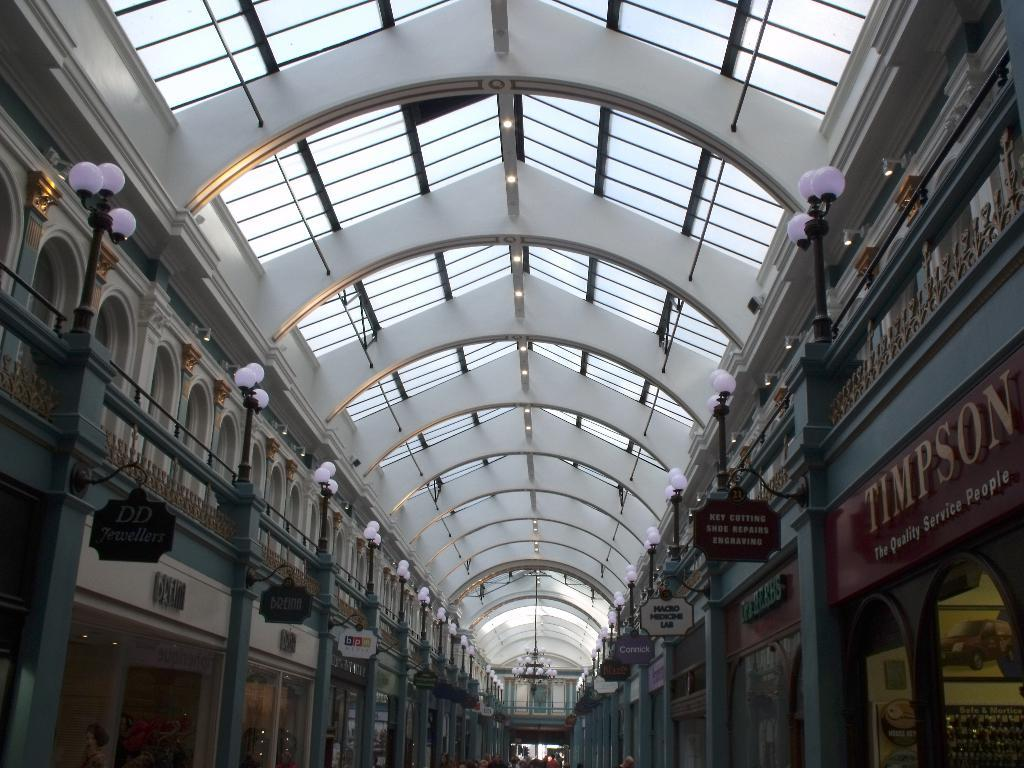What part of a building can be seen in the image? The image shows the roof of a building. What can be seen illuminating the area in the image? There are lights visible in the image. What type of signage is present in the image? Sign boards are present in the image. What structural element is visible in the image? There is a wall in the image. What material is used for the windows in the image? Glass is visible in the image. What type of decorative lighting is present in the image? A chandelier is present in the image. What type of board is used for identification purposes in the image? A naming board is present in the image. Are there any pigs visible in the image? No, there are no pigs present in the image; it shows the roof of a building with various architectural and decorative elements. 